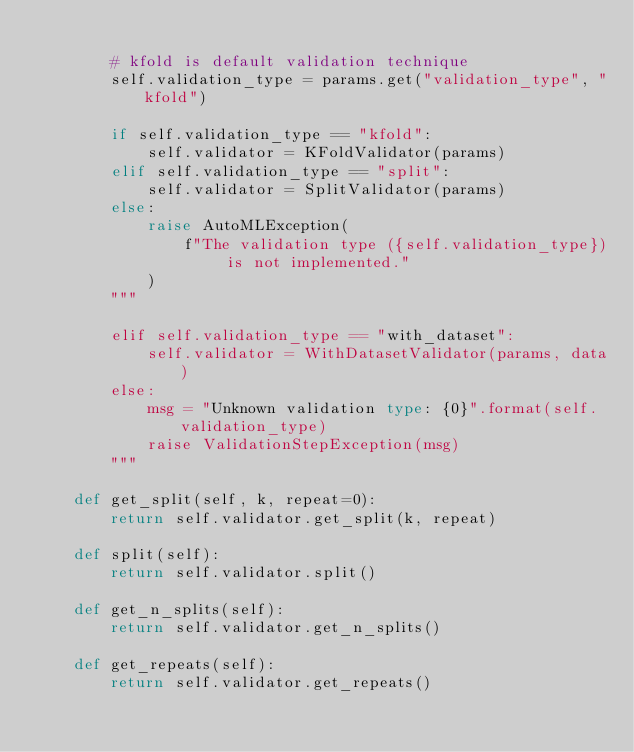<code> <loc_0><loc_0><loc_500><loc_500><_Python_>
        # kfold is default validation technique
        self.validation_type = params.get("validation_type", "kfold")

        if self.validation_type == "kfold":
            self.validator = KFoldValidator(params)
        elif self.validation_type == "split":
            self.validator = SplitValidator(params)
        else:
            raise AutoMLException(
                f"The validation type ({self.validation_type}) is not implemented."
            )
        """
        
        elif self.validation_type == "with_dataset":
            self.validator = WithDatasetValidator(params, data)
        else:
            msg = "Unknown validation type: {0}".format(self.validation_type)
            raise ValidationStepException(msg)
        """

    def get_split(self, k, repeat=0):
        return self.validator.get_split(k, repeat)

    def split(self):
        return self.validator.split()

    def get_n_splits(self):
        return self.validator.get_n_splits()

    def get_repeats(self):
        return self.validator.get_repeats()
</code> 